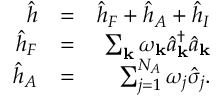<formula> <loc_0><loc_0><loc_500><loc_500>\begin{array} { r l r } { \hat { h } } & { = } & { \hat { h } _ { F } + \hat { h } _ { A } + \hat { h } _ { I } } \\ { \hat { h } _ { F } } & { = } & { \sum _ { k } \omega _ { k } \hat { a } _ { k } ^ { \dagger } \hat { a } _ { k } } \\ { \hat { h } _ { A } } & { = } & { \sum _ { j = 1 } ^ { N _ { A } } \omega _ { j } \hat { \sigma } _ { j } . } \end{array}</formula> 